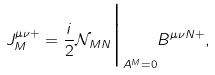<formula> <loc_0><loc_0><loc_500><loc_500>J _ { M } ^ { \mu \nu + } = \frac { i } { 2 } \mathcal { N } _ { M N } \Big | _ { A ^ { M } = 0 } B ^ { \mu \nu N + } ,</formula> 